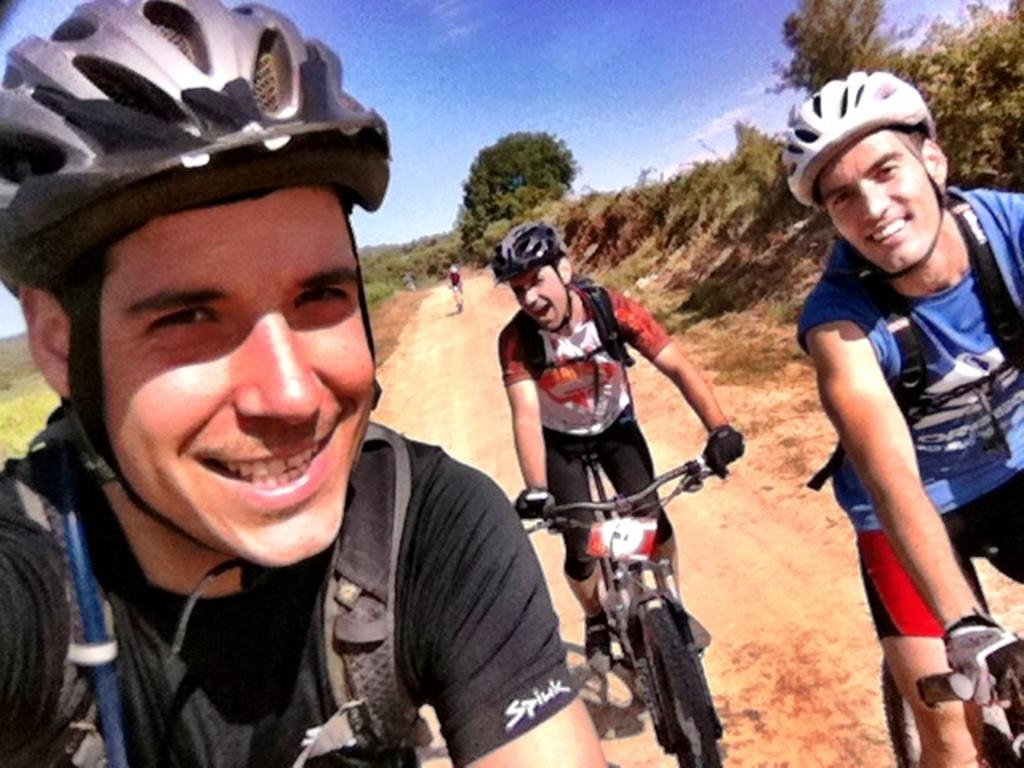How many people are in the image? There are three persons in the image. What are the persons wearing? The persons are wearing bags and helmets. What are two of the persons doing in the image? Two of the persons are on a cycle. What additional clothing items are the persons on the cycle wearing? The persons on the cycle are wearing gloves. What can be seen in the background of the image? There is a road, trees, and the sky visible in the background. What type of produce is being sold at the hospital in the image? There is no hospital or produce present in the image; it features three persons wearing bags, helmets, and gloves, with two of them on a cycle. 